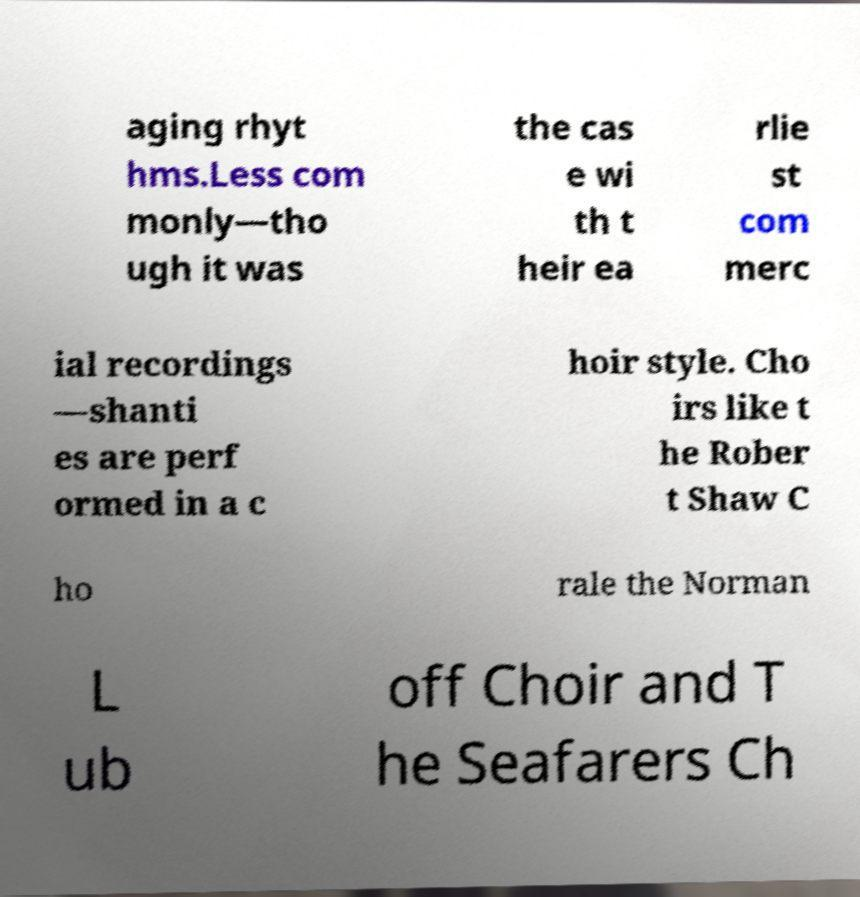Could you assist in decoding the text presented in this image and type it out clearly? aging rhyt hms.Less com monly—tho ugh it was the cas e wi th t heir ea rlie st com merc ial recordings —shanti es are perf ormed in a c hoir style. Cho irs like t he Rober t Shaw C ho rale the Norman L ub off Choir and T he Seafarers Ch 